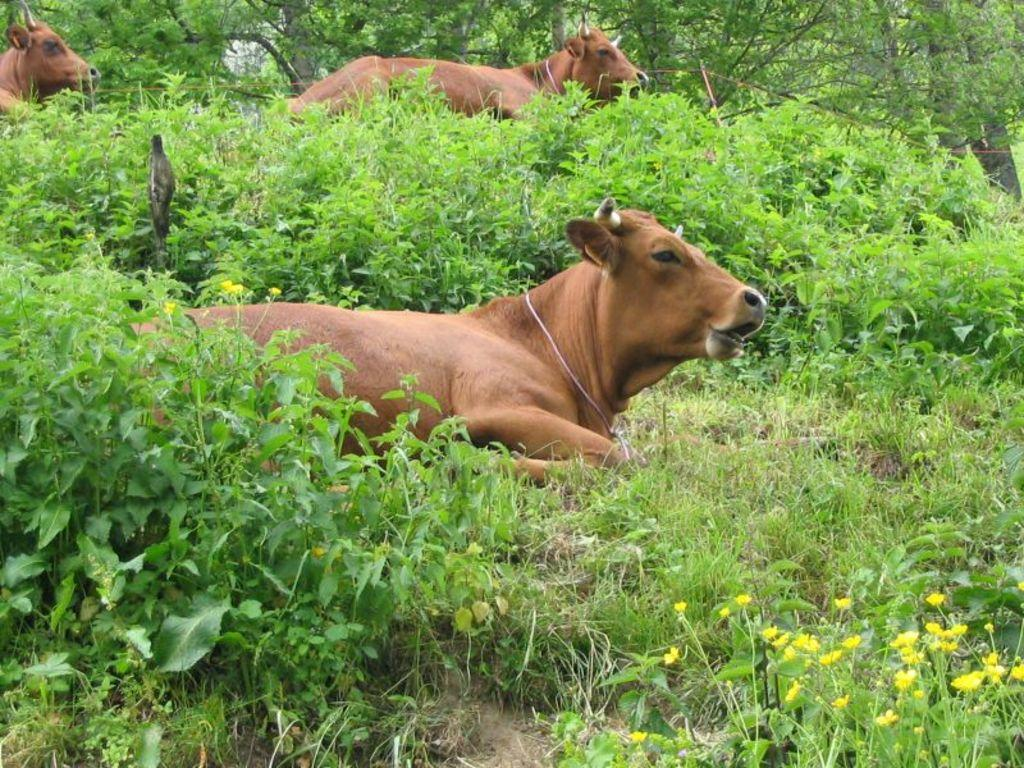What animal is sitting on the grass in the image? There is a cow sitting on the grass in the image. How many cows are present in the image? There are two cows in the image. What can be seen in the background of the image? Trees are visible in the background of the image. What type of religious symbol can be seen on the cow's wool in the image? There is no religious symbol or wool present on the cow in the image. How is the cow's wool being measured in the image? There is no wool or measurement process visible in the image. 